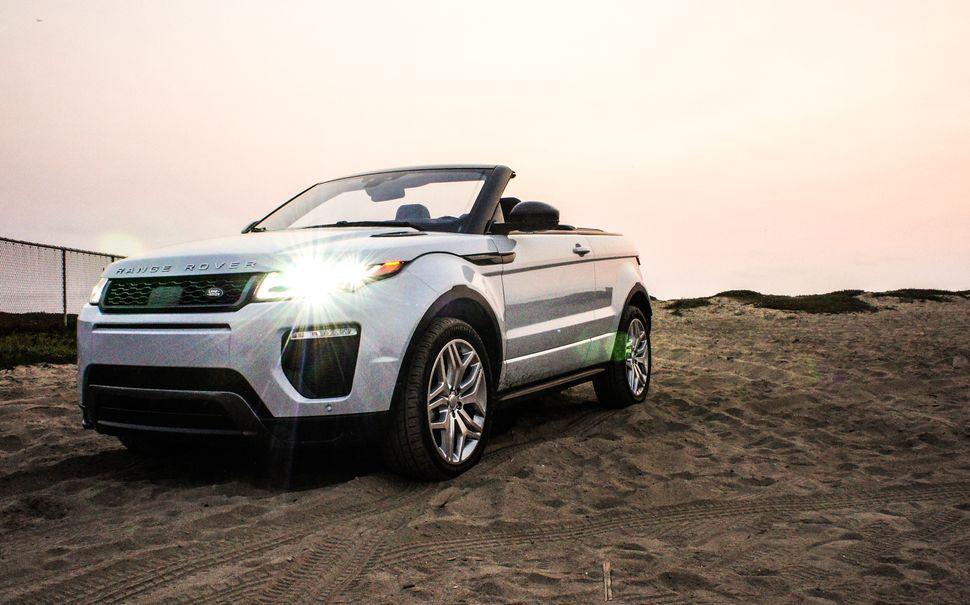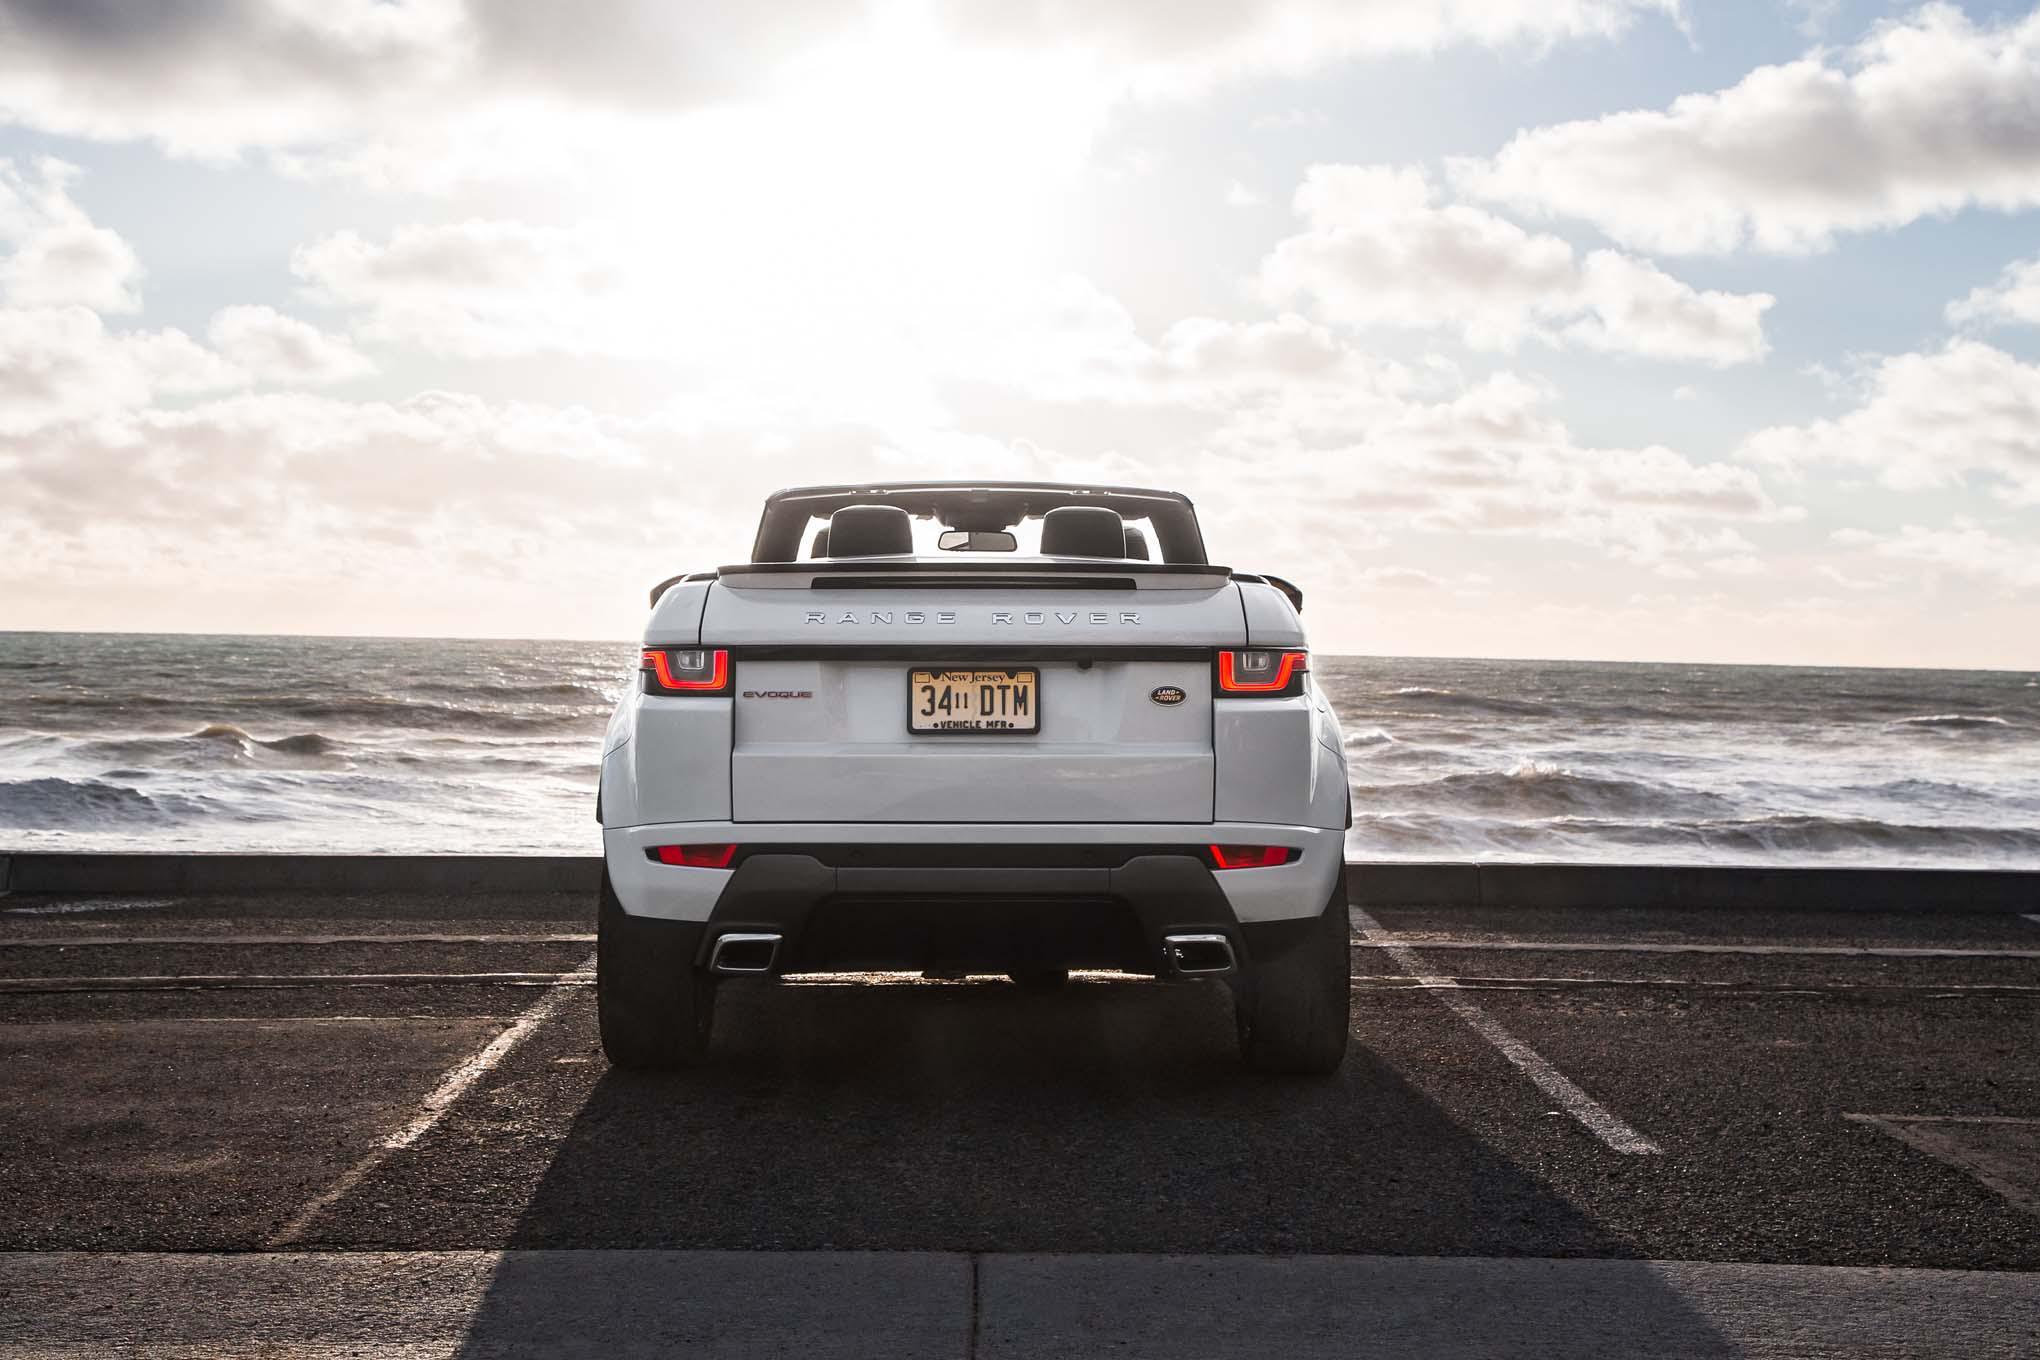The first image is the image on the left, the second image is the image on the right. Analyze the images presented: Is the assertion "The right image features one white topless convertible parked in a marked space facing the ocean, with its rear to the camera." valid? Answer yes or no. Yes. The first image is the image on the left, the second image is the image on the right. Examine the images to the left and right. Is the description "In one if the images, a car is facing the water and you can see its back licence plate." accurate? Answer yes or no. Yes. 